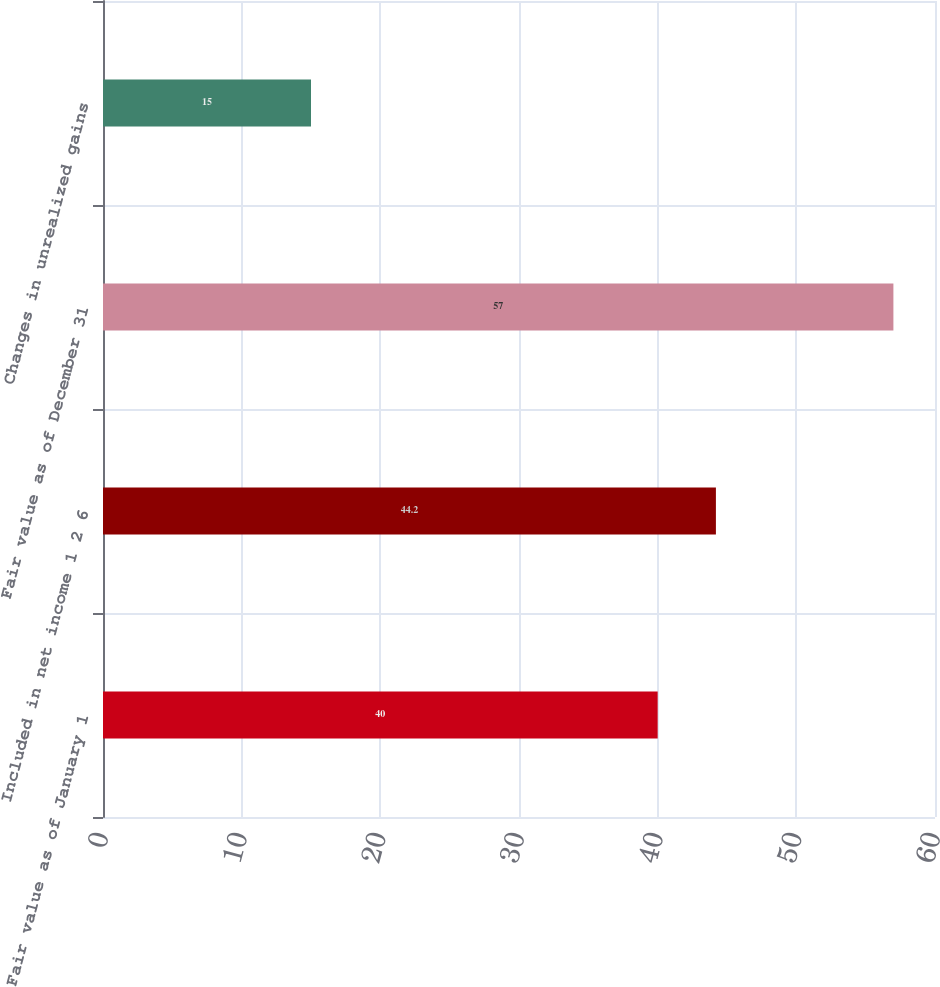Convert chart to OTSL. <chart><loc_0><loc_0><loc_500><loc_500><bar_chart><fcel>Fair value as of January 1<fcel>Included in net income 1 2 6<fcel>Fair value as of December 31<fcel>Changes in unrealized gains<nl><fcel>40<fcel>44.2<fcel>57<fcel>15<nl></chart> 